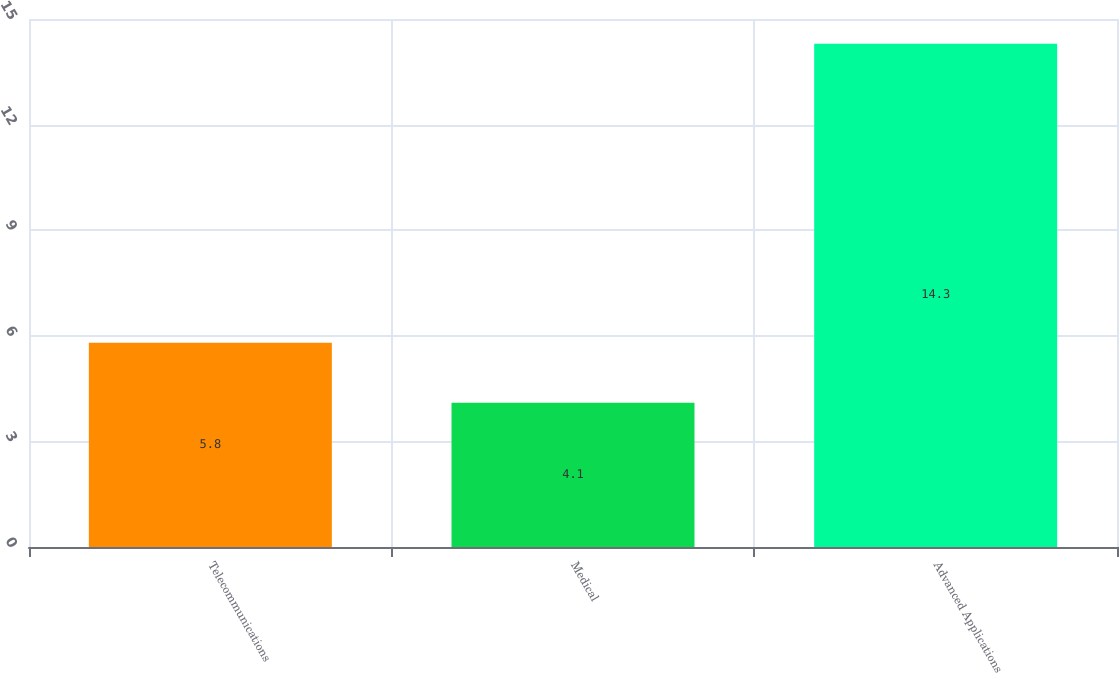<chart> <loc_0><loc_0><loc_500><loc_500><bar_chart><fcel>Telecommunications<fcel>Medical<fcel>Advanced Applications<nl><fcel>5.8<fcel>4.1<fcel>14.3<nl></chart> 